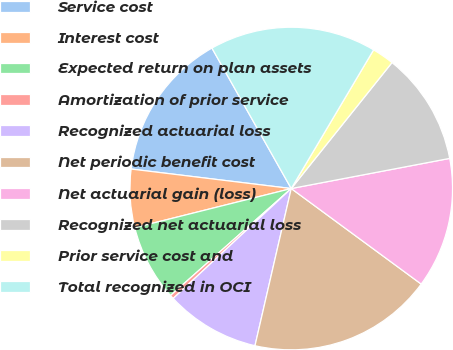Convert chart. <chart><loc_0><loc_0><loc_500><loc_500><pie_chart><fcel>Service cost<fcel>Interest cost<fcel>Expected return on plan assets<fcel>Amortization of prior service<fcel>Recognized actuarial loss<fcel>Net periodic benefit cost<fcel>Net actuarial gain (loss)<fcel>Recognized net actuarial loss<fcel>Prior service cost and<fcel>Total recognized in OCI<nl><fcel>14.89%<fcel>5.83%<fcel>7.64%<fcel>0.39%<fcel>9.46%<fcel>18.52%<fcel>13.08%<fcel>11.27%<fcel>2.21%<fcel>16.71%<nl></chart> 